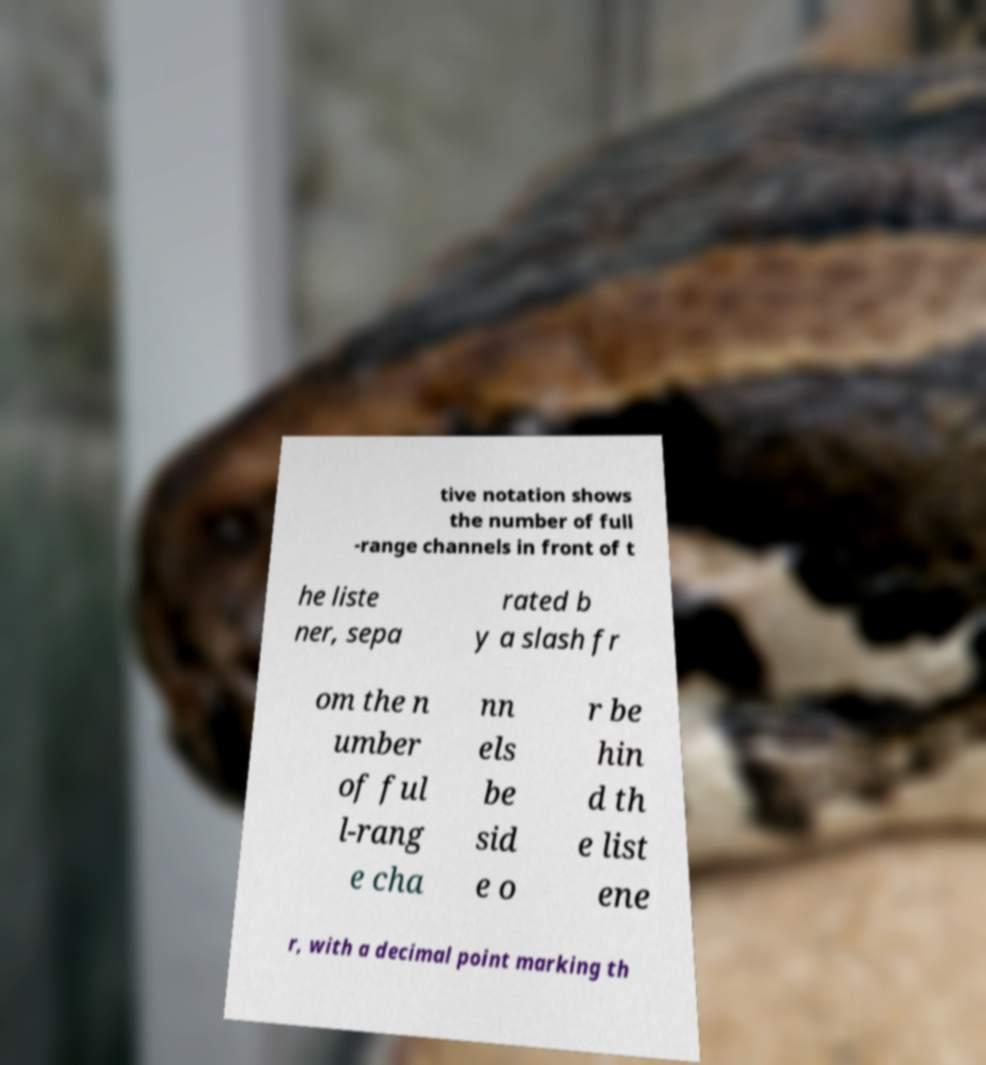What messages or text are displayed in this image? I need them in a readable, typed format. tive notation shows the number of full -range channels in front of t he liste ner, sepa rated b y a slash fr om the n umber of ful l-rang e cha nn els be sid e o r be hin d th e list ene r, with a decimal point marking th 